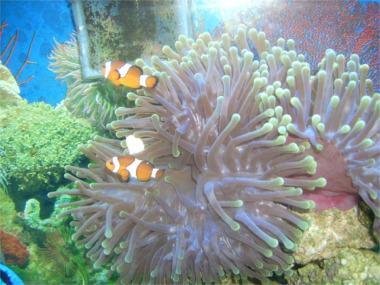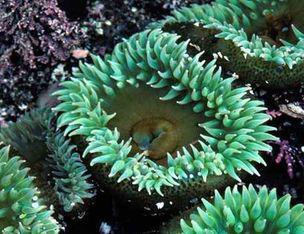The first image is the image on the left, the second image is the image on the right. Evaluate the accuracy of this statement regarding the images: "One image shows a flower-like anemone with mint green tendrils and a darker yellowish center with a visible slit in it.". Is it true? Answer yes or no. Yes. 